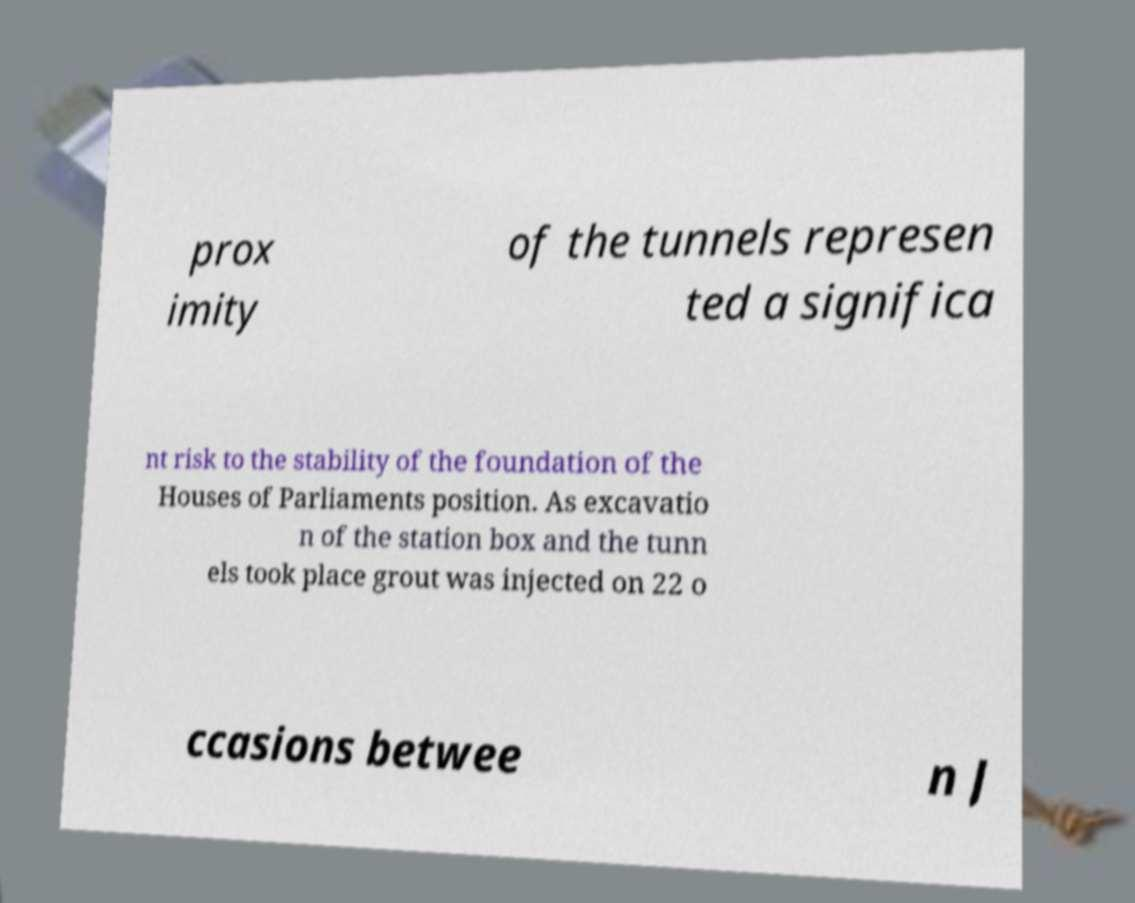Could you assist in decoding the text presented in this image and type it out clearly? prox imity of the tunnels represen ted a significa nt risk to the stability of the foundation of the Houses of Parliaments position. As excavatio n of the station box and the tunn els took place grout was injected on 22 o ccasions betwee n J 